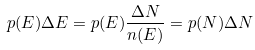<formula> <loc_0><loc_0><loc_500><loc_500>p ( E ) \Delta E = p ( E ) \frac { \Delta N } { n ( E ) } = p ( N ) \Delta N</formula> 